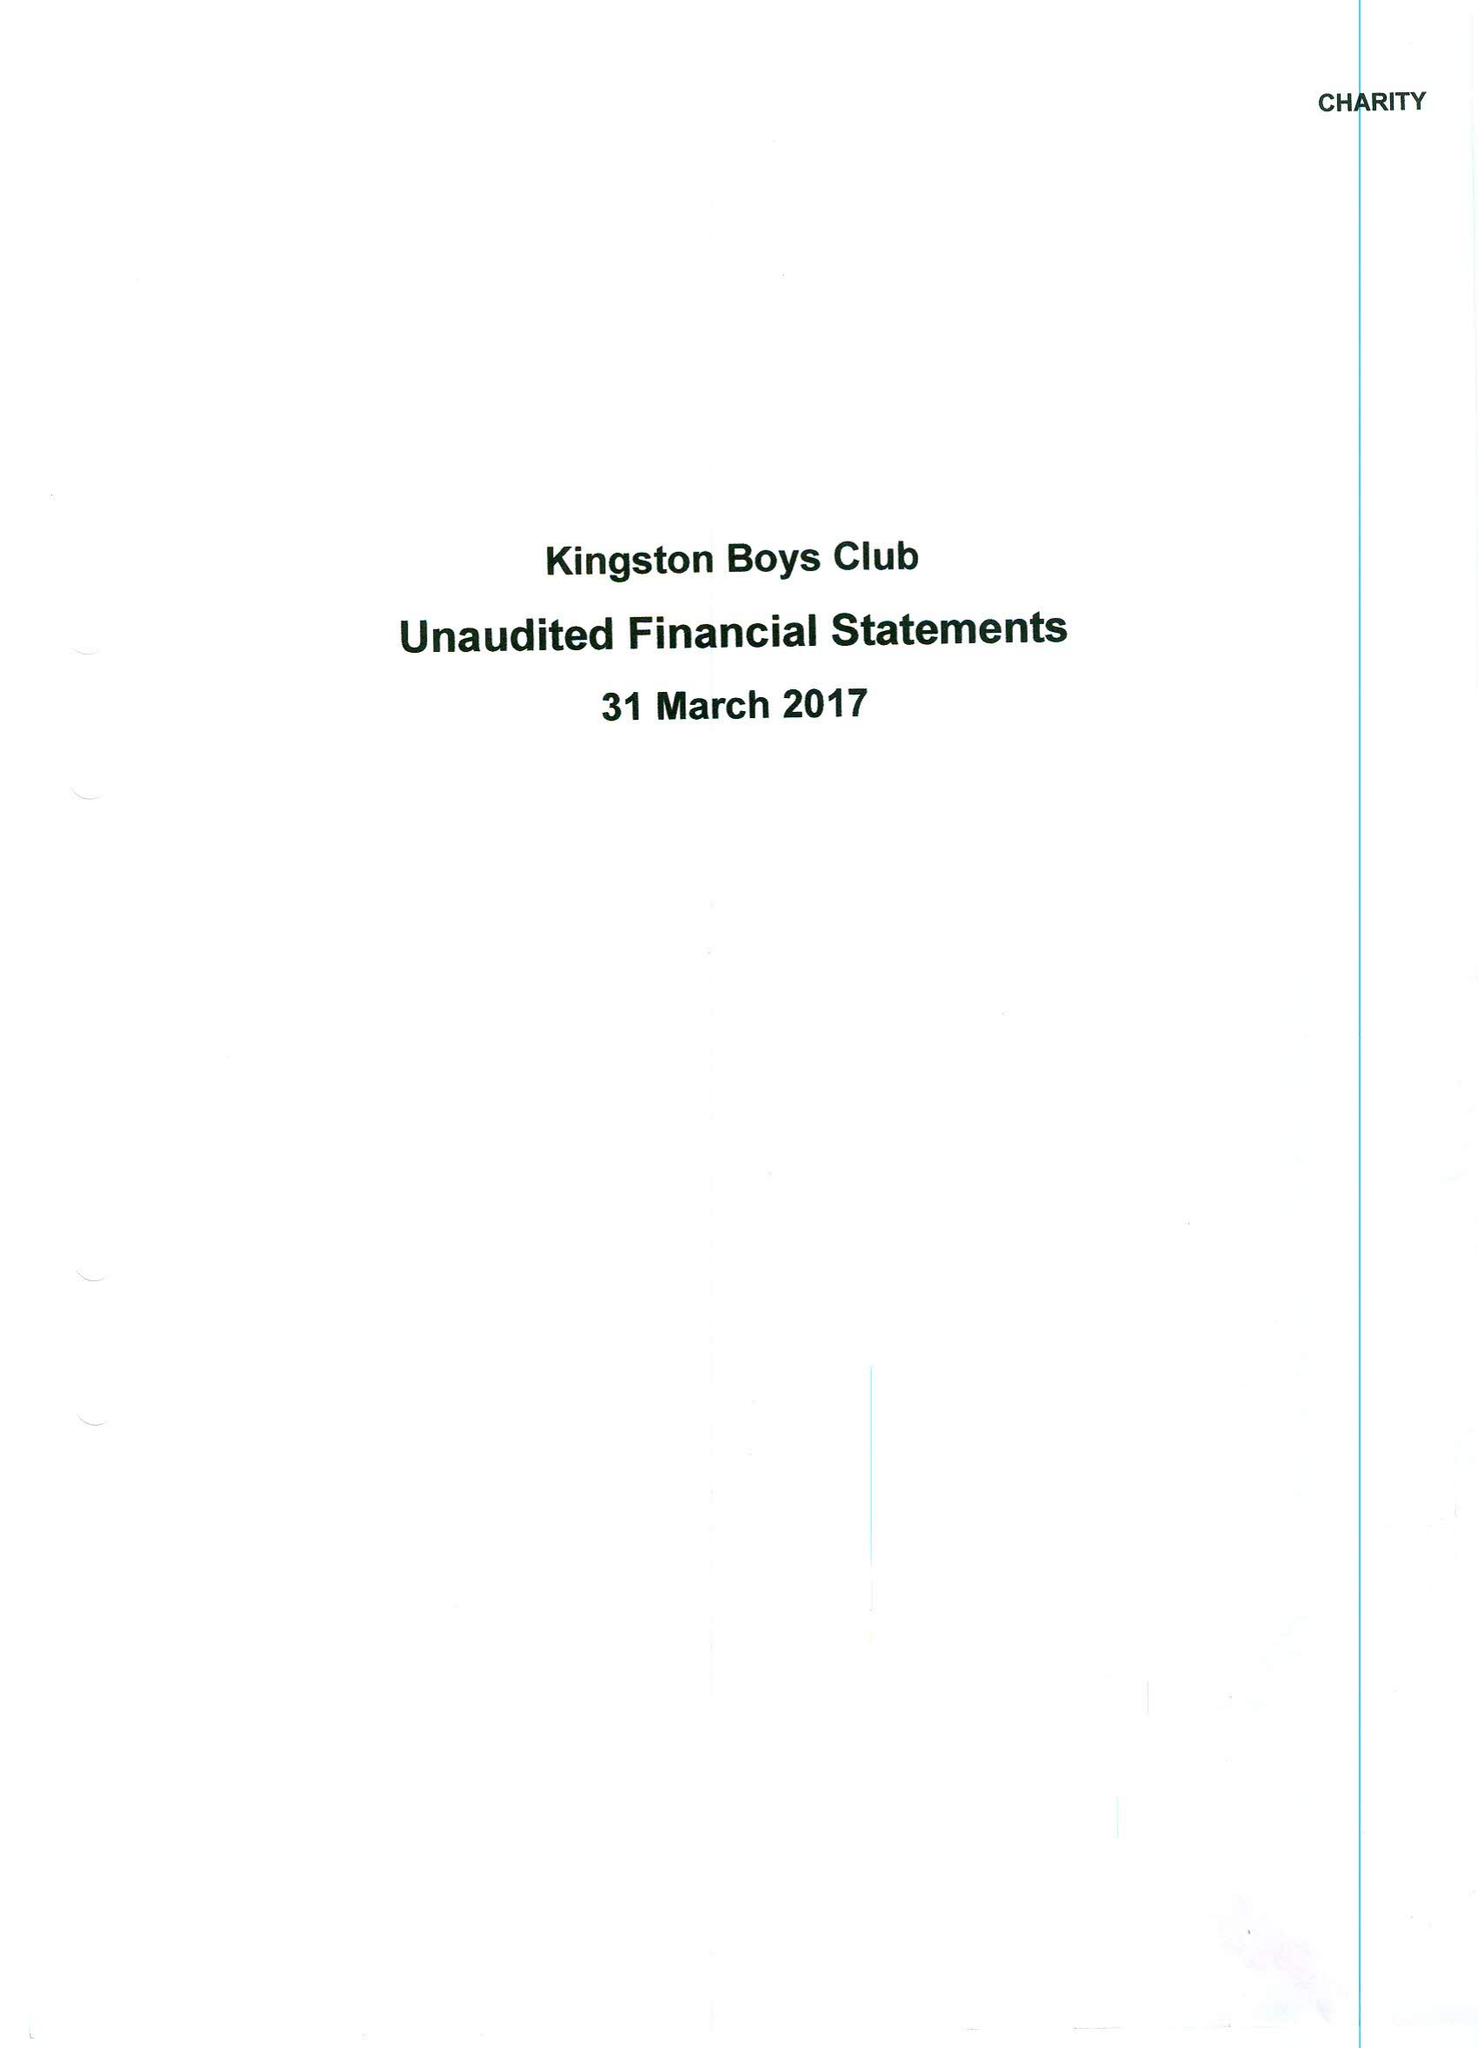What is the value for the address__post_town?
Answer the question using a single word or phrase. KINGSTON UPON THAMES 